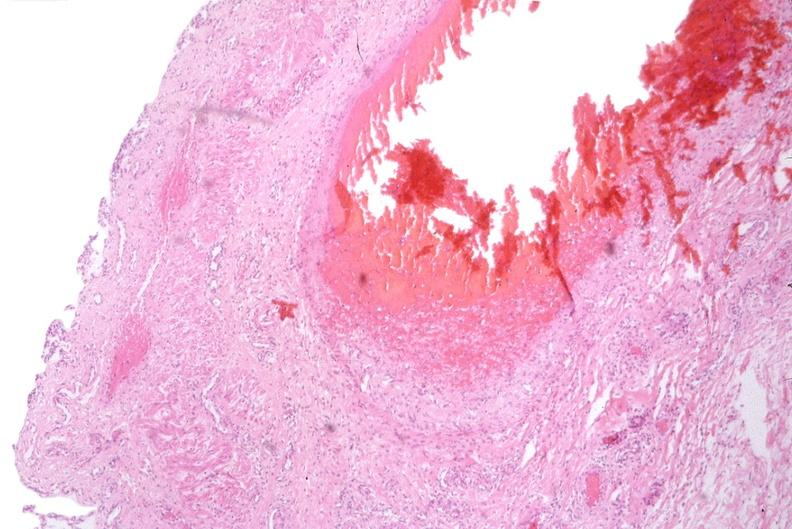what is present?
Answer the question using a single word or phrase. Gastrointestinal 